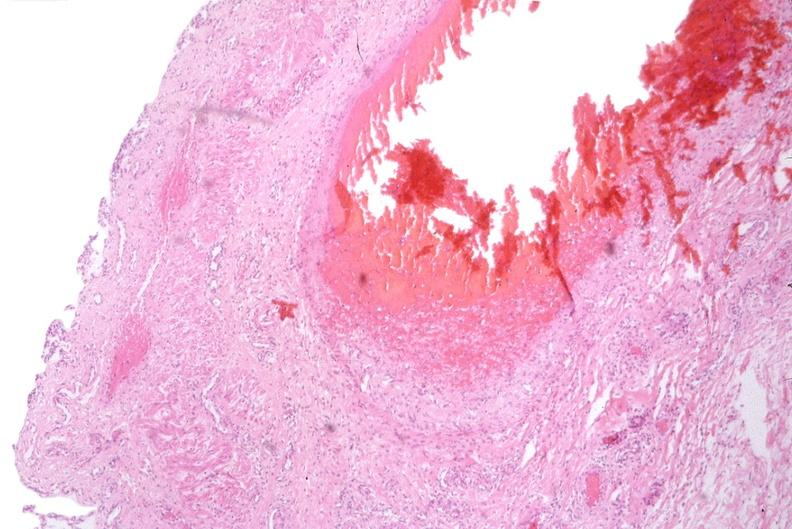what is present?
Answer the question using a single word or phrase. Gastrointestinal 